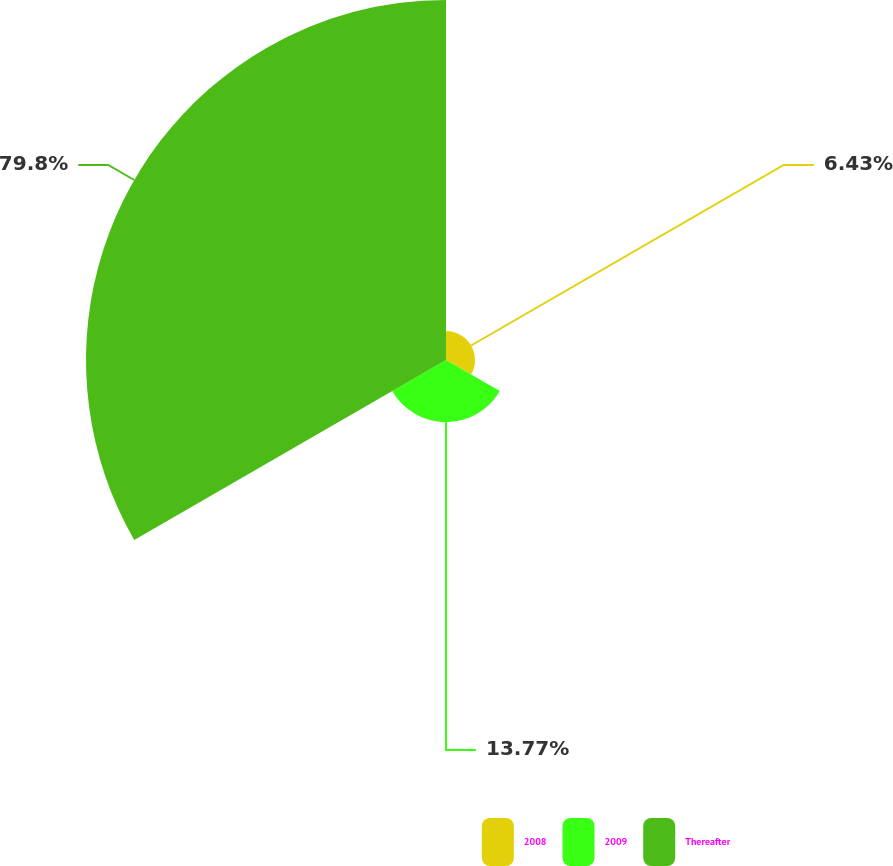<chart> <loc_0><loc_0><loc_500><loc_500><pie_chart><fcel>2008<fcel>2009<fcel>Thereafter<nl><fcel>6.43%<fcel>13.77%<fcel>79.79%<nl></chart> 